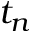Convert formula to latex. <formula><loc_0><loc_0><loc_500><loc_500>t _ { n }</formula> 